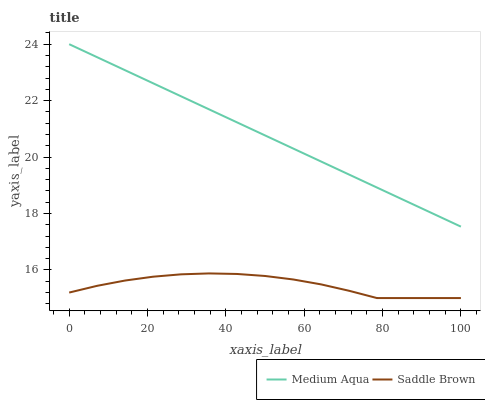Does Saddle Brown have the minimum area under the curve?
Answer yes or no. Yes. Does Medium Aqua have the maximum area under the curve?
Answer yes or no. Yes. Does Saddle Brown have the maximum area under the curve?
Answer yes or no. No. Is Medium Aqua the smoothest?
Answer yes or no. Yes. Is Saddle Brown the roughest?
Answer yes or no. Yes. Is Saddle Brown the smoothest?
Answer yes or no. No. Does Saddle Brown have the lowest value?
Answer yes or no. Yes. Does Medium Aqua have the highest value?
Answer yes or no. Yes. Does Saddle Brown have the highest value?
Answer yes or no. No. Is Saddle Brown less than Medium Aqua?
Answer yes or no. Yes. Is Medium Aqua greater than Saddle Brown?
Answer yes or no. Yes. Does Saddle Brown intersect Medium Aqua?
Answer yes or no. No. 